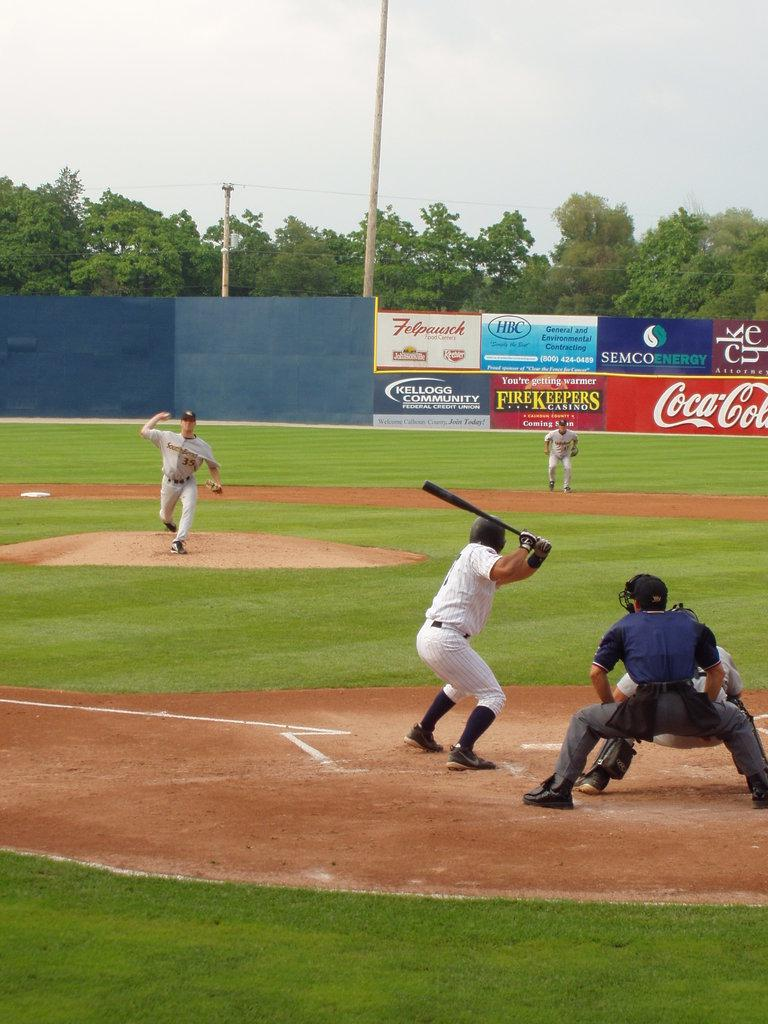<image>
Render a clear and concise summary of the photo. A pitcher wearing a gray uniform with the number 35 is about to release the ball while the batter waits  and umpire watches. 